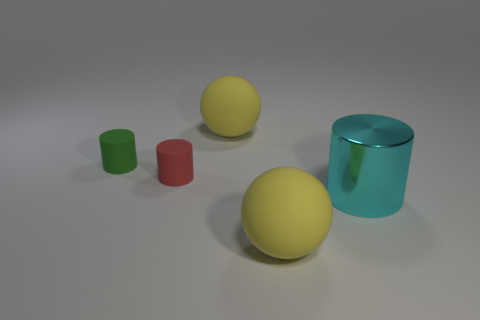Add 3 big spheres. How many objects exist? 8 Subtract all spheres. How many objects are left? 3 Add 1 small red things. How many small red things exist? 2 Subtract 1 cyan cylinders. How many objects are left? 4 Subtract all objects. Subtract all brown objects. How many objects are left? 0 Add 5 cyan metal objects. How many cyan metal objects are left? 6 